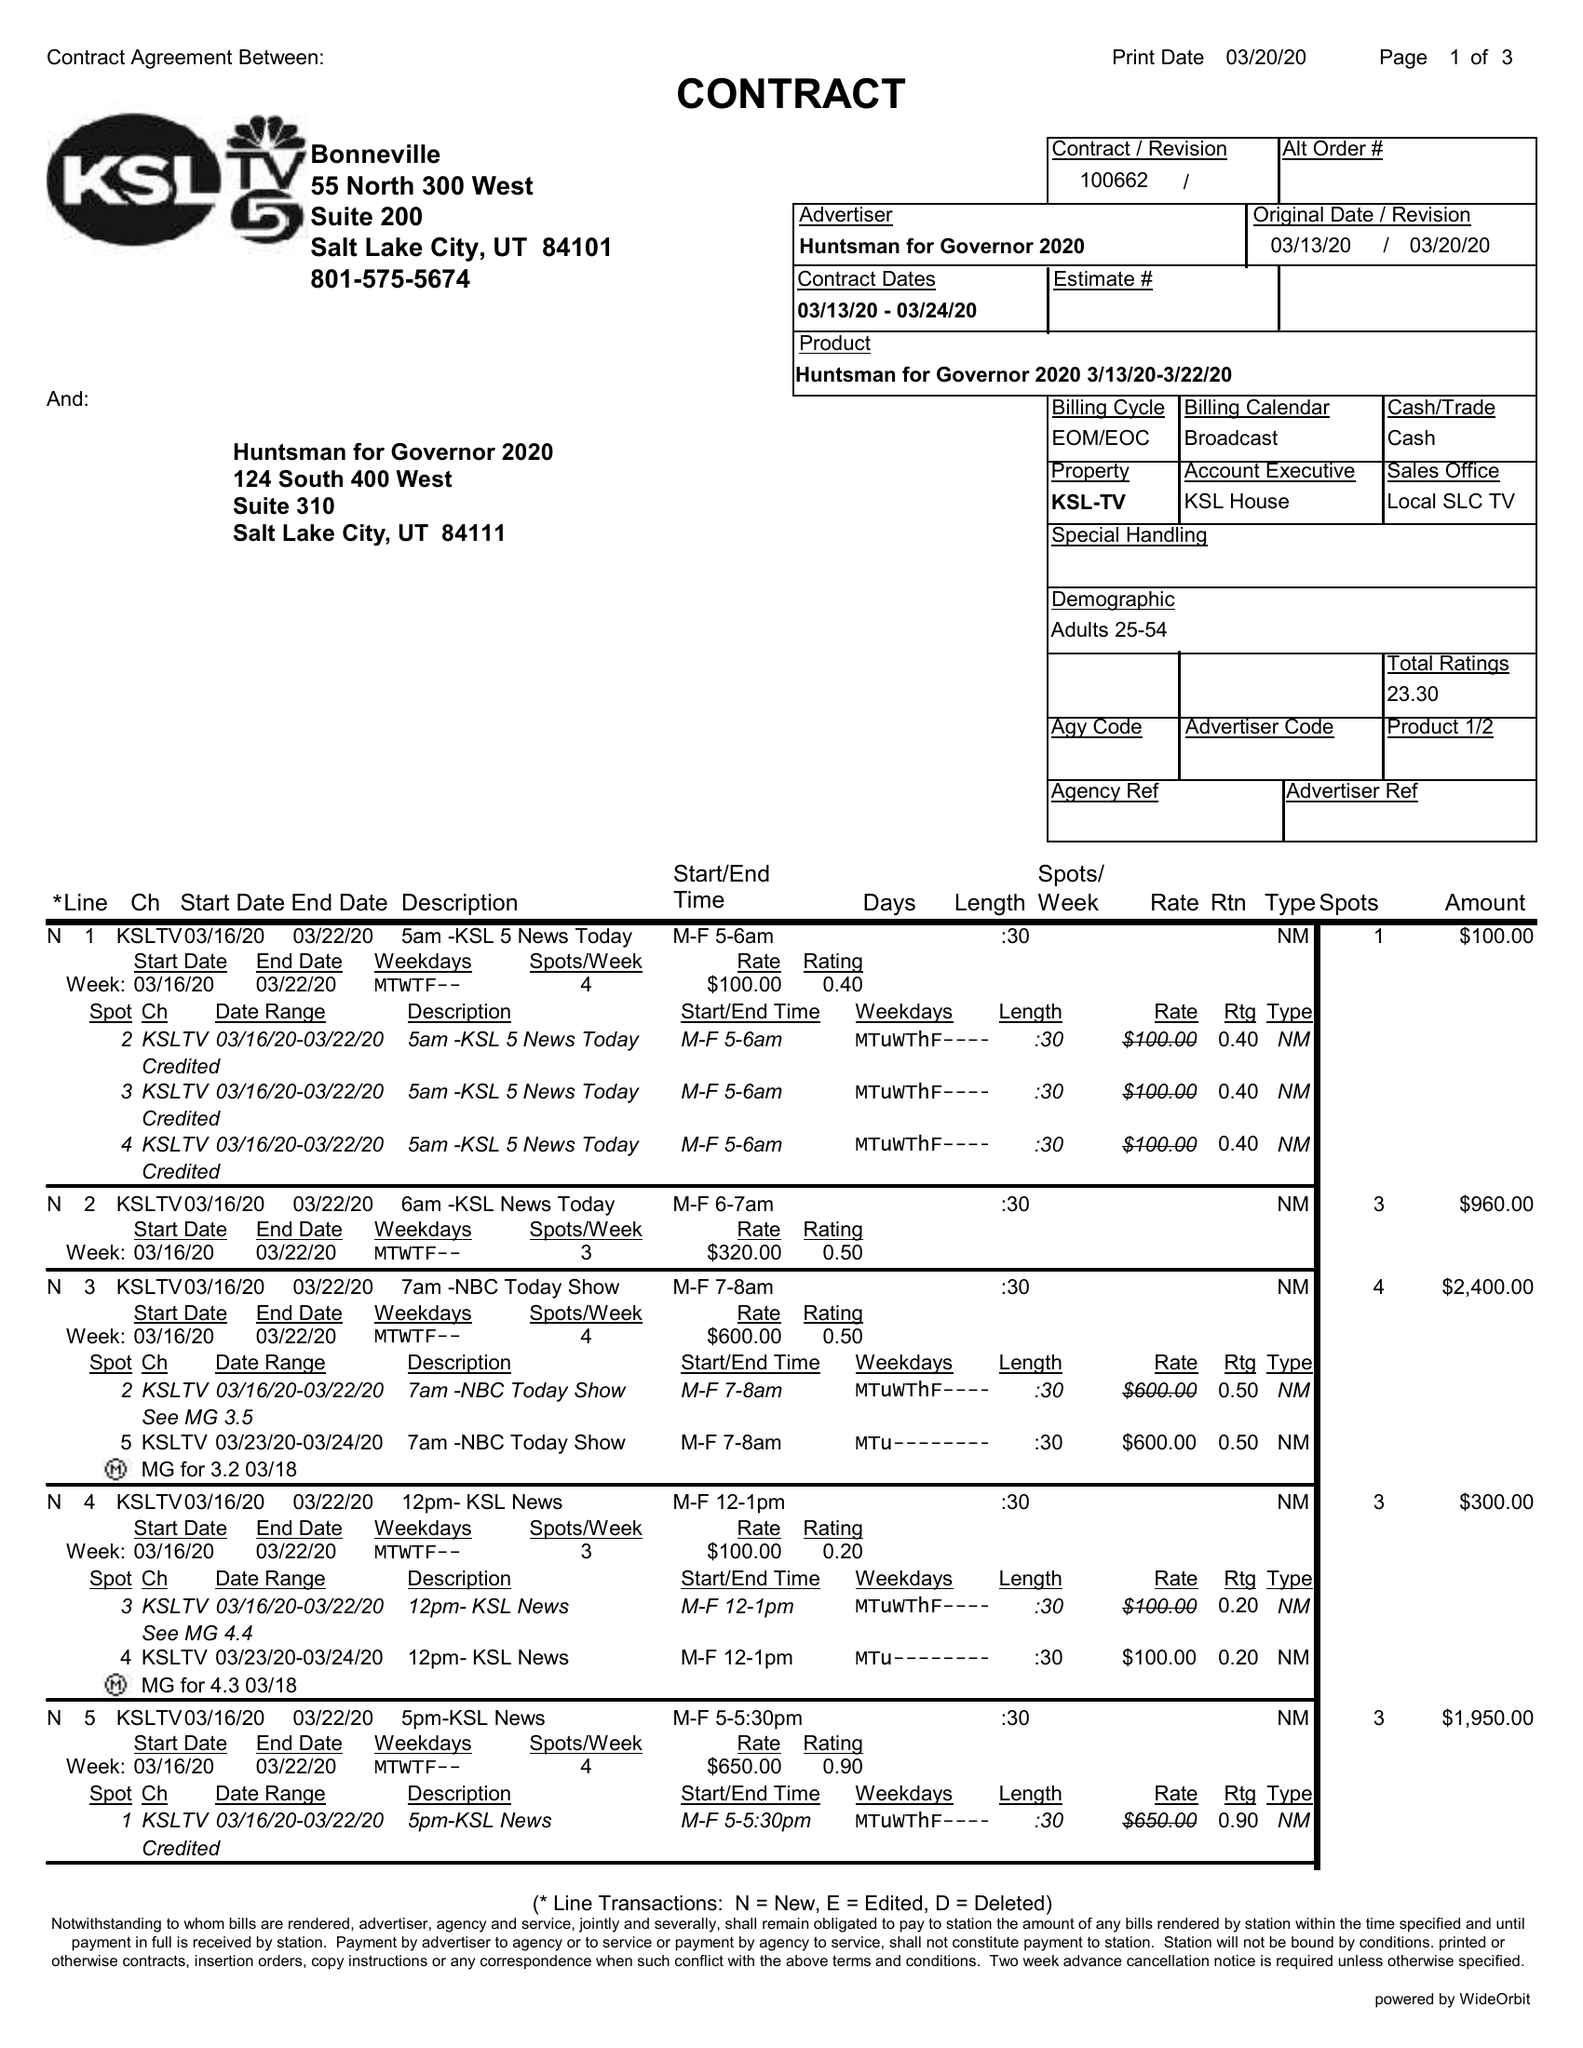What is the value for the advertiser?
Answer the question using a single word or phrase. HUNTSMAN FOR GOVERNOR 2020 